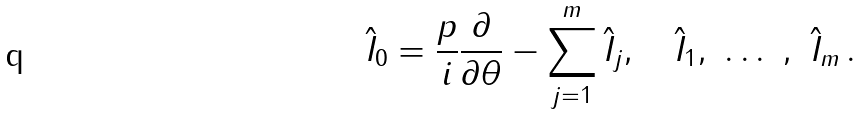<formula> <loc_0><loc_0><loc_500><loc_500>\hat { I } _ { 0 } = \frac { p } { i } \frac { \partial } { \partial \theta } - \sum _ { j = 1 } ^ { m } \hat { I } _ { j } , \quad \hat { I } _ { 1 } , \ \dots \ , \ \hat { I } _ { m } \, .</formula> 